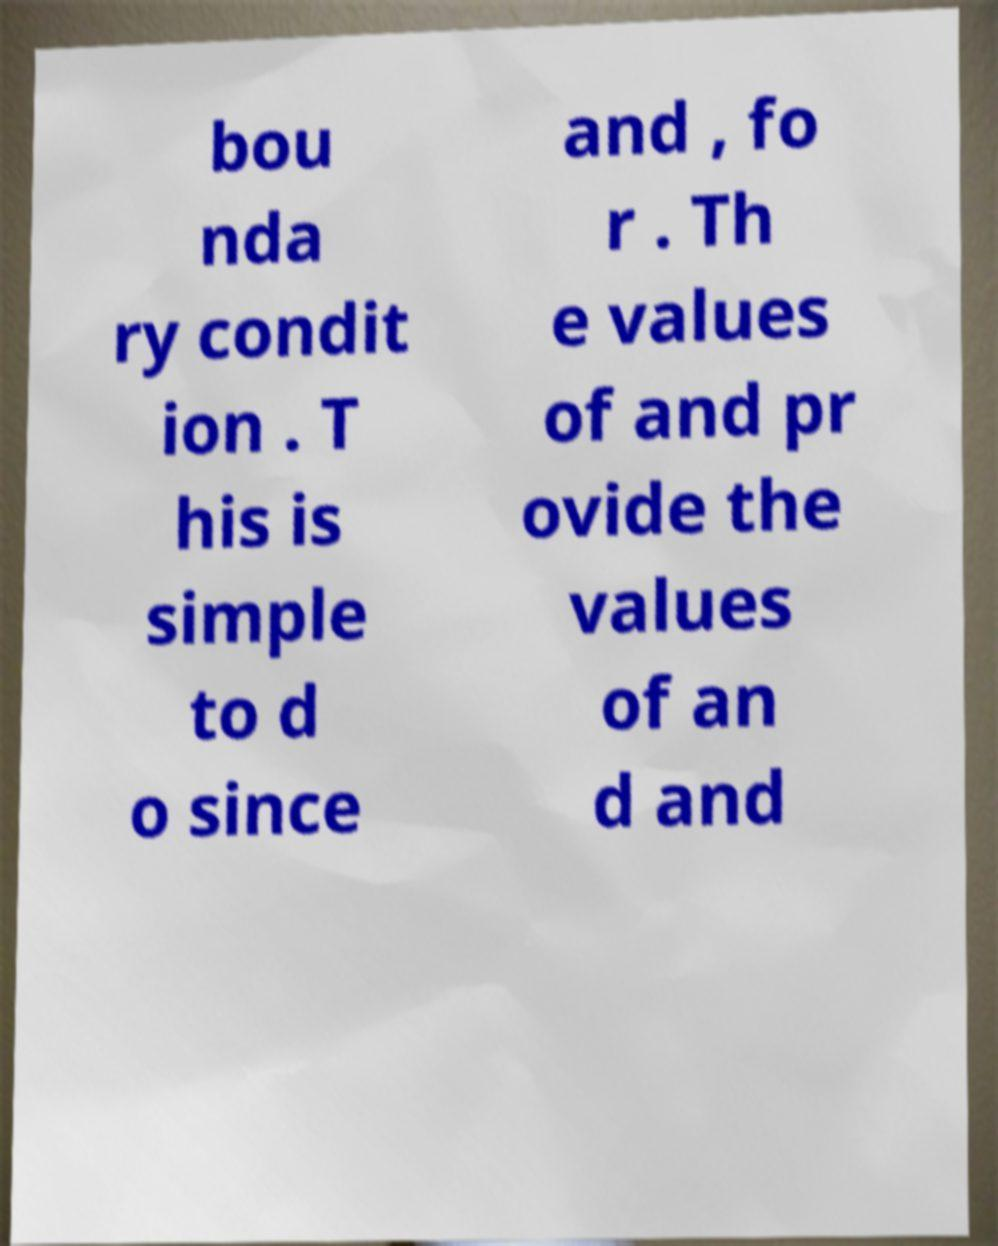Can you accurately transcribe the text from the provided image for me? bou nda ry condit ion . T his is simple to d o since and , fo r . Th e values of and pr ovide the values of an d and 